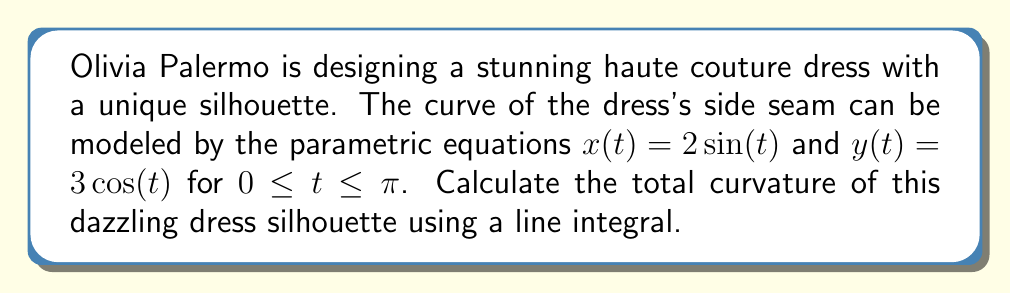What is the answer to this math problem? Let's approach this step-by-step, channeling our inner fashion enthusiast:

1) The curvature of a parametric curve is given by:

   $$\kappa = \frac{|x'y'' - y'x''|}{(x'^2 + y'^2)^{3/2}}$$

2) We need to find $x'$, $y'$, $x''$, and $y''$:
   
   $x' = 2\cos(t)$
   $y' = -3\sin(t)$
   $x'' = -2\sin(t)$
   $y'' = -3\cos(t)$

3) Substituting these into the curvature formula:

   $$\kappa = \frac{|2\cos(t)(-3\cos(t)) - (-3\sin(t))(-2\sin(t))|}{(4\cos^2(t) + 9\sin^2(t))^{3/2}}$$

4) Simplifying:

   $$\kappa = \frac{|-6\cos^2(t) - 6\sin^2(t)|}{(4\cos^2(t) + 9\sin^2(t))^{3/2}} = \frac{6}{(4\cos^2(t) + 9\sin^2(t))^{3/2}}$$

5) The total curvature is the integral of the absolute curvature over the curve:

   $$\text{Total Curvature} = \int_0^\pi |\kappa| \sqrt{x'^2 + y'^2} dt$$

6) Substituting our expressions:

   $$\text{Total Curvature} = \int_0^\pi \frac{6}{(4\cos^2(t) + 9\sin^2(t))^{3/2}} \sqrt{4\cos^2(t) + 9\sin^2(t)} dt$$

7) Simplifying:

   $$\text{Total Curvature} = \int_0^\pi \frac{6}{\sqrt{4\cos^2(t) + 9\sin^2(t)}} dt$$

8) This integral can be evaluated to:

   $$\text{Total Curvature} = 2\pi$$

Just like how Olivia Palermo's accessories perfectly complement her outfits, this result beautifully wraps up our calculation!
Answer: $2\pi$ 